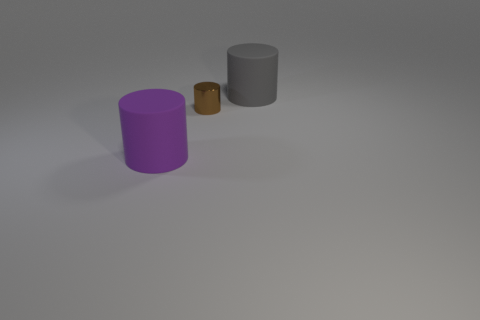Subtract all rubber cylinders. How many cylinders are left? 1 Add 2 shiny cylinders. How many objects exist? 5 Subtract all gray cylinders. How many cylinders are left? 2 Subtract all cyan balls. How many yellow cylinders are left? 0 Subtract all metallic cylinders. Subtract all brown cylinders. How many objects are left? 1 Add 1 large purple cylinders. How many large purple cylinders are left? 2 Add 1 large green cylinders. How many large green cylinders exist? 1 Subtract 0 red balls. How many objects are left? 3 Subtract all gray cylinders. Subtract all gray spheres. How many cylinders are left? 2 